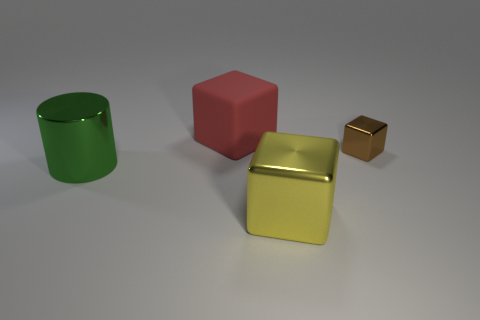There is a shiny cube behind the big block in front of the small object; what is its color?
Offer a terse response. Brown. There is a cube that is to the right of the large red rubber cube and on the left side of the brown block; what material is it?
Give a very brief answer. Metal. Is there a brown matte ball that has the same size as the green metal cylinder?
Ensure brevity in your answer.  No. There is a yellow cube that is the same size as the metal cylinder; what is its material?
Offer a terse response. Metal. There is a large cylinder; what number of big metallic cubes are on the right side of it?
Your answer should be very brief. 1. Is the shape of the metallic object that is on the right side of the big yellow metal object the same as  the big red object?
Keep it short and to the point. Yes. Is there another rubber object that has the same shape as the yellow thing?
Your response must be concise. Yes. There is a big thing left of the big cube that is behind the green metallic cylinder; what shape is it?
Keep it short and to the point. Cylinder. What number of other big green objects are made of the same material as the green thing?
Keep it short and to the point. 0. There is a big object that is made of the same material as the large cylinder; what color is it?
Your answer should be compact. Yellow. 